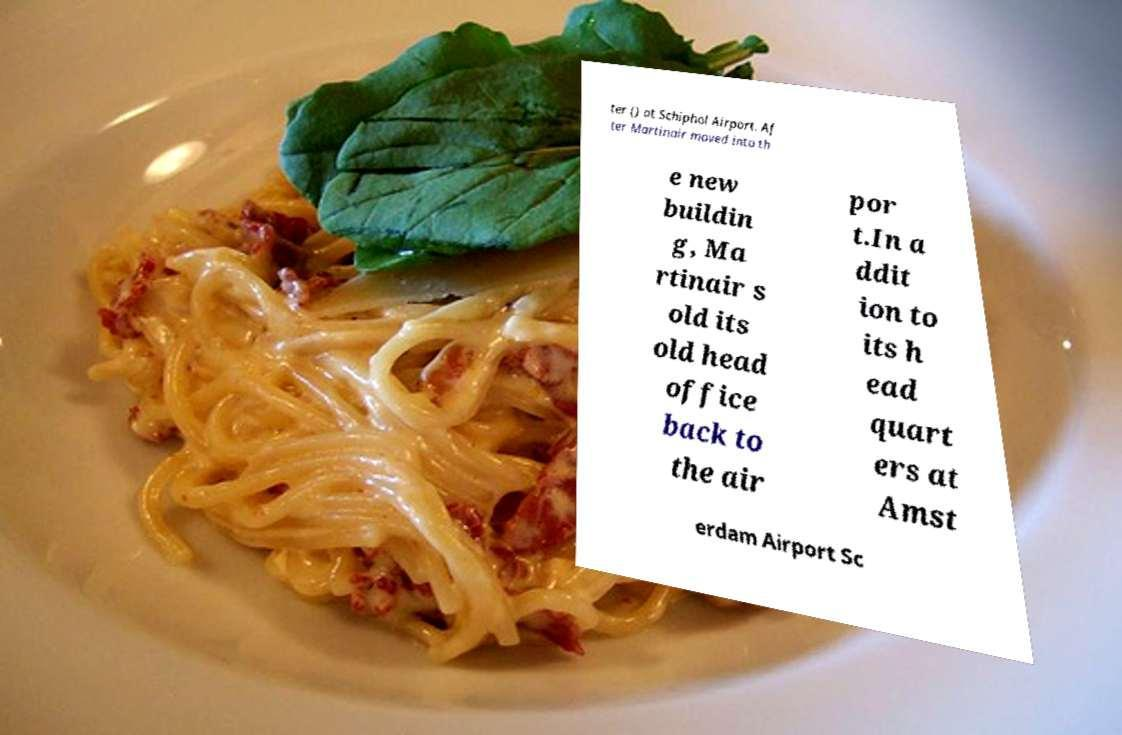Please identify and transcribe the text found in this image. ter () at Schiphol Airport. Af ter Martinair moved into th e new buildin g, Ma rtinair s old its old head office back to the air por t.In a ddit ion to its h ead quart ers at Amst erdam Airport Sc 